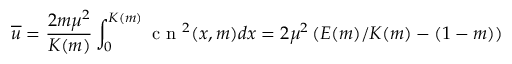<formula> <loc_0><loc_0><loc_500><loc_500>\overline { u } = \frac { 2 m \mu ^ { 2 } } { K ( m ) } \int _ { 0 } ^ { K ( m ) } c n ^ { 2 } ( x , m ) d x = 2 \mu ^ { 2 } \left ( E ( m ) / K ( m ) - ( 1 - m ) \right )</formula> 